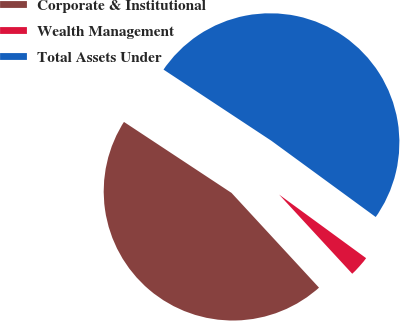Convert chart. <chart><loc_0><loc_0><loc_500><loc_500><pie_chart><fcel>Corporate & Institutional<fcel>Wealth Management<fcel>Total Assets Under<nl><fcel>46.15%<fcel>3.09%<fcel>50.76%<nl></chart> 